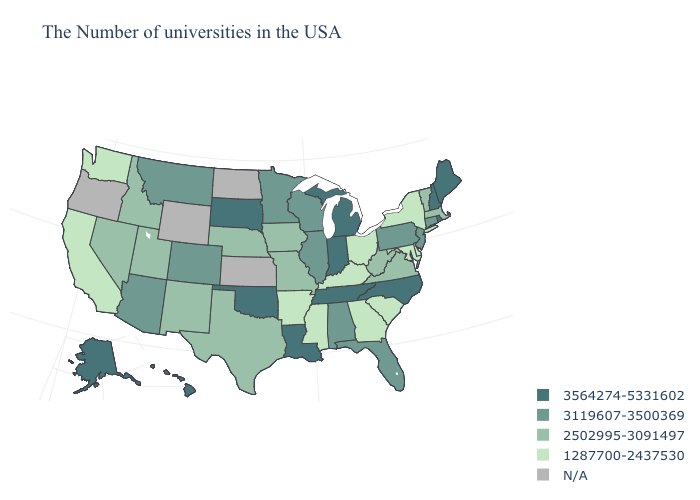Which states have the lowest value in the West?
Give a very brief answer. California, Washington. What is the value of Georgia?
Short answer required. 1287700-2437530. Does North Carolina have the lowest value in the South?
Write a very short answer. No. What is the value of Utah?
Short answer required. 2502995-3091497. What is the value of Indiana?
Give a very brief answer. 3564274-5331602. What is the value of Montana?
Write a very short answer. 3119607-3500369. What is the value of Colorado?
Concise answer only. 3119607-3500369. Name the states that have a value in the range 2502995-3091497?
Answer briefly. Massachusetts, Vermont, Virginia, West Virginia, Missouri, Iowa, Nebraska, Texas, New Mexico, Utah, Idaho, Nevada. What is the value of North Carolina?
Write a very short answer. 3564274-5331602. Among the states that border Michigan , which have the highest value?
Be succinct. Indiana. What is the value of California?
Answer briefly. 1287700-2437530. Among the states that border Utah , which have the highest value?
Write a very short answer. Colorado, Arizona. Is the legend a continuous bar?
Give a very brief answer. No. What is the highest value in the Northeast ?
Give a very brief answer. 3564274-5331602. 